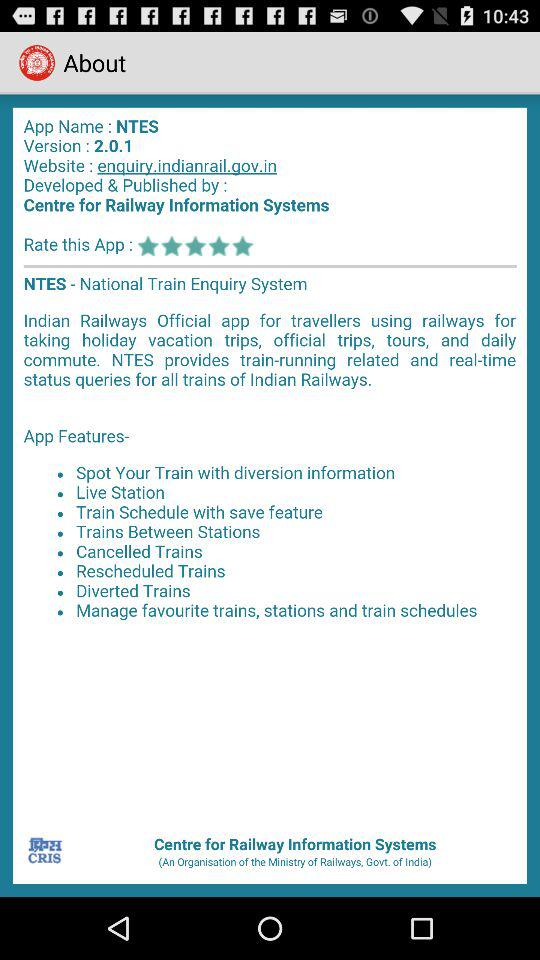What's the website name? The website name is enquiry.indianrail.gov.in. 